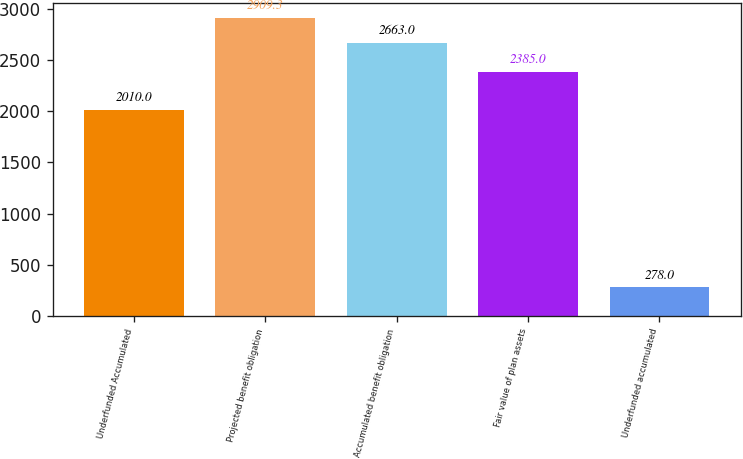<chart> <loc_0><loc_0><loc_500><loc_500><bar_chart><fcel>Underfunded Accumulated<fcel>Projected benefit obligation<fcel>Accumulated benefit obligation<fcel>Fair value of plan assets<fcel>Underfunded accumulated<nl><fcel>2010<fcel>2909.3<fcel>2663<fcel>2385<fcel>278<nl></chart> 